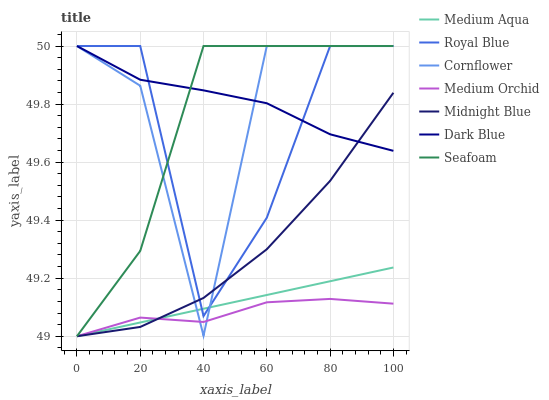Does Medium Orchid have the minimum area under the curve?
Answer yes or no. Yes. Does Dark Blue have the maximum area under the curve?
Answer yes or no. Yes. Does Midnight Blue have the minimum area under the curve?
Answer yes or no. No. Does Midnight Blue have the maximum area under the curve?
Answer yes or no. No. Is Medium Aqua the smoothest?
Answer yes or no. Yes. Is Cornflower the roughest?
Answer yes or no. Yes. Is Midnight Blue the smoothest?
Answer yes or no. No. Is Midnight Blue the roughest?
Answer yes or no. No. Does Medium Orchid have the lowest value?
Answer yes or no. Yes. Does Midnight Blue have the lowest value?
Answer yes or no. No. Does Royal Blue have the highest value?
Answer yes or no. Yes. Does Midnight Blue have the highest value?
Answer yes or no. No. Is Medium Orchid less than Royal Blue?
Answer yes or no. Yes. Is Royal Blue greater than Medium Orchid?
Answer yes or no. Yes. Does Cornflower intersect Midnight Blue?
Answer yes or no. Yes. Is Cornflower less than Midnight Blue?
Answer yes or no. No. Is Cornflower greater than Midnight Blue?
Answer yes or no. No. Does Medium Orchid intersect Royal Blue?
Answer yes or no. No. 